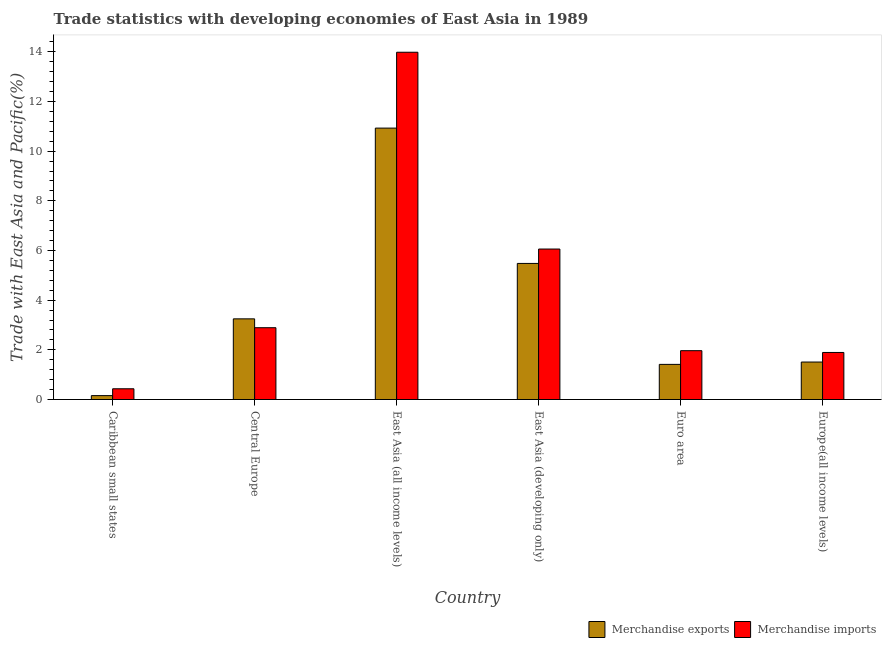How many different coloured bars are there?
Offer a terse response. 2. Are the number of bars per tick equal to the number of legend labels?
Your answer should be compact. Yes. Are the number of bars on each tick of the X-axis equal?
Keep it short and to the point. Yes. How many bars are there on the 1st tick from the right?
Your answer should be compact. 2. What is the label of the 4th group of bars from the left?
Provide a short and direct response. East Asia (developing only). In how many cases, is the number of bars for a given country not equal to the number of legend labels?
Provide a succinct answer. 0. What is the merchandise imports in East Asia (developing only)?
Offer a terse response. 6.06. Across all countries, what is the maximum merchandise imports?
Make the answer very short. 13.98. Across all countries, what is the minimum merchandise exports?
Provide a succinct answer. 0.16. In which country was the merchandise imports maximum?
Your answer should be very brief. East Asia (all income levels). In which country was the merchandise imports minimum?
Offer a terse response. Caribbean small states. What is the total merchandise exports in the graph?
Ensure brevity in your answer.  22.74. What is the difference between the merchandise imports in Central Europe and that in East Asia (developing only)?
Your response must be concise. -3.17. What is the difference between the merchandise exports in Euro area and the merchandise imports in Caribbean small states?
Make the answer very short. 0.98. What is the average merchandise imports per country?
Your response must be concise. 4.54. What is the difference between the merchandise exports and merchandise imports in East Asia (developing only)?
Your response must be concise. -0.58. In how many countries, is the merchandise exports greater than 8.8 %?
Offer a terse response. 1. What is the ratio of the merchandise imports in Central Europe to that in Europe(all income levels)?
Provide a succinct answer. 1.53. Is the merchandise exports in Central Europe less than that in East Asia (all income levels)?
Provide a short and direct response. Yes. What is the difference between the highest and the second highest merchandise exports?
Your answer should be very brief. 5.45. What is the difference between the highest and the lowest merchandise exports?
Offer a terse response. 10.77. How many legend labels are there?
Keep it short and to the point. 2. How are the legend labels stacked?
Offer a terse response. Horizontal. What is the title of the graph?
Ensure brevity in your answer.  Trade statistics with developing economies of East Asia in 1989. What is the label or title of the X-axis?
Give a very brief answer. Country. What is the label or title of the Y-axis?
Offer a terse response. Trade with East Asia and Pacific(%). What is the Trade with East Asia and Pacific(%) of Merchandise exports in Caribbean small states?
Offer a very short reply. 0.16. What is the Trade with East Asia and Pacific(%) of Merchandise imports in Caribbean small states?
Make the answer very short. 0.43. What is the Trade with East Asia and Pacific(%) of Merchandise exports in Central Europe?
Ensure brevity in your answer.  3.25. What is the Trade with East Asia and Pacific(%) of Merchandise imports in Central Europe?
Offer a very short reply. 2.89. What is the Trade with East Asia and Pacific(%) of Merchandise exports in East Asia (all income levels)?
Offer a very short reply. 10.93. What is the Trade with East Asia and Pacific(%) in Merchandise imports in East Asia (all income levels)?
Ensure brevity in your answer.  13.98. What is the Trade with East Asia and Pacific(%) of Merchandise exports in East Asia (developing only)?
Make the answer very short. 5.48. What is the Trade with East Asia and Pacific(%) in Merchandise imports in East Asia (developing only)?
Keep it short and to the point. 6.06. What is the Trade with East Asia and Pacific(%) of Merchandise exports in Euro area?
Your response must be concise. 1.41. What is the Trade with East Asia and Pacific(%) of Merchandise imports in Euro area?
Ensure brevity in your answer.  1.97. What is the Trade with East Asia and Pacific(%) of Merchandise exports in Europe(all income levels)?
Your answer should be compact. 1.51. What is the Trade with East Asia and Pacific(%) in Merchandise imports in Europe(all income levels)?
Offer a terse response. 1.89. Across all countries, what is the maximum Trade with East Asia and Pacific(%) of Merchandise exports?
Offer a terse response. 10.93. Across all countries, what is the maximum Trade with East Asia and Pacific(%) of Merchandise imports?
Your response must be concise. 13.98. Across all countries, what is the minimum Trade with East Asia and Pacific(%) of Merchandise exports?
Your response must be concise. 0.16. Across all countries, what is the minimum Trade with East Asia and Pacific(%) of Merchandise imports?
Offer a very short reply. 0.43. What is the total Trade with East Asia and Pacific(%) of Merchandise exports in the graph?
Keep it short and to the point. 22.74. What is the total Trade with East Asia and Pacific(%) of Merchandise imports in the graph?
Give a very brief answer. 27.23. What is the difference between the Trade with East Asia and Pacific(%) in Merchandise exports in Caribbean small states and that in Central Europe?
Ensure brevity in your answer.  -3.09. What is the difference between the Trade with East Asia and Pacific(%) in Merchandise imports in Caribbean small states and that in Central Europe?
Keep it short and to the point. -2.46. What is the difference between the Trade with East Asia and Pacific(%) of Merchandise exports in Caribbean small states and that in East Asia (all income levels)?
Provide a succinct answer. -10.77. What is the difference between the Trade with East Asia and Pacific(%) in Merchandise imports in Caribbean small states and that in East Asia (all income levels)?
Offer a terse response. -13.55. What is the difference between the Trade with East Asia and Pacific(%) of Merchandise exports in Caribbean small states and that in East Asia (developing only)?
Ensure brevity in your answer.  -5.32. What is the difference between the Trade with East Asia and Pacific(%) of Merchandise imports in Caribbean small states and that in East Asia (developing only)?
Your answer should be very brief. -5.63. What is the difference between the Trade with East Asia and Pacific(%) of Merchandise exports in Caribbean small states and that in Euro area?
Provide a succinct answer. -1.26. What is the difference between the Trade with East Asia and Pacific(%) in Merchandise imports in Caribbean small states and that in Euro area?
Make the answer very short. -1.53. What is the difference between the Trade with East Asia and Pacific(%) of Merchandise exports in Caribbean small states and that in Europe(all income levels)?
Your answer should be very brief. -1.35. What is the difference between the Trade with East Asia and Pacific(%) of Merchandise imports in Caribbean small states and that in Europe(all income levels)?
Offer a very short reply. -1.46. What is the difference between the Trade with East Asia and Pacific(%) of Merchandise exports in Central Europe and that in East Asia (all income levels)?
Provide a succinct answer. -7.68. What is the difference between the Trade with East Asia and Pacific(%) of Merchandise imports in Central Europe and that in East Asia (all income levels)?
Offer a very short reply. -11.09. What is the difference between the Trade with East Asia and Pacific(%) in Merchandise exports in Central Europe and that in East Asia (developing only)?
Offer a terse response. -2.23. What is the difference between the Trade with East Asia and Pacific(%) of Merchandise imports in Central Europe and that in East Asia (developing only)?
Your answer should be compact. -3.17. What is the difference between the Trade with East Asia and Pacific(%) of Merchandise exports in Central Europe and that in Euro area?
Give a very brief answer. 1.83. What is the difference between the Trade with East Asia and Pacific(%) of Merchandise imports in Central Europe and that in Euro area?
Your answer should be compact. 0.92. What is the difference between the Trade with East Asia and Pacific(%) of Merchandise exports in Central Europe and that in Europe(all income levels)?
Your answer should be very brief. 1.74. What is the difference between the Trade with East Asia and Pacific(%) in Merchandise exports in East Asia (all income levels) and that in East Asia (developing only)?
Offer a very short reply. 5.45. What is the difference between the Trade with East Asia and Pacific(%) in Merchandise imports in East Asia (all income levels) and that in East Asia (developing only)?
Your response must be concise. 7.92. What is the difference between the Trade with East Asia and Pacific(%) in Merchandise exports in East Asia (all income levels) and that in Euro area?
Your answer should be very brief. 9.51. What is the difference between the Trade with East Asia and Pacific(%) of Merchandise imports in East Asia (all income levels) and that in Euro area?
Ensure brevity in your answer.  12.02. What is the difference between the Trade with East Asia and Pacific(%) in Merchandise exports in East Asia (all income levels) and that in Europe(all income levels)?
Offer a terse response. 9.42. What is the difference between the Trade with East Asia and Pacific(%) in Merchandise imports in East Asia (all income levels) and that in Europe(all income levels)?
Give a very brief answer. 12.09. What is the difference between the Trade with East Asia and Pacific(%) in Merchandise exports in East Asia (developing only) and that in Euro area?
Offer a terse response. 4.06. What is the difference between the Trade with East Asia and Pacific(%) of Merchandise imports in East Asia (developing only) and that in Euro area?
Offer a terse response. 4.09. What is the difference between the Trade with East Asia and Pacific(%) in Merchandise exports in East Asia (developing only) and that in Europe(all income levels)?
Keep it short and to the point. 3.97. What is the difference between the Trade with East Asia and Pacific(%) in Merchandise imports in East Asia (developing only) and that in Europe(all income levels)?
Offer a terse response. 4.16. What is the difference between the Trade with East Asia and Pacific(%) of Merchandise exports in Euro area and that in Europe(all income levels)?
Provide a short and direct response. -0.09. What is the difference between the Trade with East Asia and Pacific(%) in Merchandise imports in Euro area and that in Europe(all income levels)?
Your response must be concise. 0.07. What is the difference between the Trade with East Asia and Pacific(%) in Merchandise exports in Caribbean small states and the Trade with East Asia and Pacific(%) in Merchandise imports in Central Europe?
Provide a short and direct response. -2.73. What is the difference between the Trade with East Asia and Pacific(%) of Merchandise exports in Caribbean small states and the Trade with East Asia and Pacific(%) of Merchandise imports in East Asia (all income levels)?
Your answer should be very brief. -13.83. What is the difference between the Trade with East Asia and Pacific(%) in Merchandise exports in Caribbean small states and the Trade with East Asia and Pacific(%) in Merchandise imports in East Asia (developing only)?
Your response must be concise. -5.9. What is the difference between the Trade with East Asia and Pacific(%) of Merchandise exports in Caribbean small states and the Trade with East Asia and Pacific(%) of Merchandise imports in Euro area?
Make the answer very short. -1.81. What is the difference between the Trade with East Asia and Pacific(%) of Merchandise exports in Caribbean small states and the Trade with East Asia and Pacific(%) of Merchandise imports in Europe(all income levels)?
Provide a succinct answer. -1.74. What is the difference between the Trade with East Asia and Pacific(%) of Merchandise exports in Central Europe and the Trade with East Asia and Pacific(%) of Merchandise imports in East Asia (all income levels)?
Make the answer very short. -10.73. What is the difference between the Trade with East Asia and Pacific(%) of Merchandise exports in Central Europe and the Trade with East Asia and Pacific(%) of Merchandise imports in East Asia (developing only)?
Offer a very short reply. -2.81. What is the difference between the Trade with East Asia and Pacific(%) of Merchandise exports in Central Europe and the Trade with East Asia and Pacific(%) of Merchandise imports in Euro area?
Your response must be concise. 1.28. What is the difference between the Trade with East Asia and Pacific(%) in Merchandise exports in Central Europe and the Trade with East Asia and Pacific(%) in Merchandise imports in Europe(all income levels)?
Make the answer very short. 1.35. What is the difference between the Trade with East Asia and Pacific(%) of Merchandise exports in East Asia (all income levels) and the Trade with East Asia and Pacific(%) of Merchandise imports in East Asia (developing only)?
Offer a terse response. 4.87. What is the difference between the Trade with East Asia and Pacific(%) in Merchandise exports in East Asia (all income levels) and the Trade with East Asia and Pacific(%) in Merchandise imports in Euro area?
Make the answer very short. 8.96. What is the difference between the Trade with East Asia and Pacific(%) in Merchandise exports in East Asia (all income levels) and the Trade with East Asia and Pacific(%) in Merchandise imports in Europe(all income levels)?
Provide a short and direct response. 9.03. What is the difference between the Trade with East Asia and Pacific(%) of Merchandise exports in East Asia (developing only) and the Trade with East Asia and Pacific(%) of Merchandise imports in Euro area?
Make the answer very short. 3.51. What is the difference between the Trade with East Asia and Pacific(%) in Merchandise exports in East Asia (developing only) and the Trade with East Asia and Pacific(%) in Merchandise imports in Europe(all income levels)?
Ensure brevity in your answer.  3.58. What is the difference between the Trade with East Asia and Pacific(%) in Merchandise exports in Euro area and the Trade with East Asia and Pacific(%) in Merchandise imports in Europe(all income levels)?
Your answer should be very brief. -0.48. What is the average Trade with East Asia and Pacific(%) in Merchandise exports per country?
Provide a short and direct response. 3.79. What is the average Trade with East Asia and Pacific(%) of Merchandise imports per country?
Your response must be concise. 4.54. What is the difference between the Trade with East Asia and Pacific(%) in Merchandise exports and Trade with East Asia and Pacific(%) in Merchandise imports in Caribbean small states?
Keep it short and to the point. -0.28. What is the difference between the Trade with East Asia and Pacific(%) in Merchandise exports and Trade with East Asia and Pacific(%) in Merchandise imports in Central Europe?
Give a very brief answer. 0.36. What is the difference between the Trade with East Asia and Pacific(%) of Merchandise exports and Trade with East Asia and Pacific(%) of Merchandise imports in East Asia (all income levels)?
Keep it short and to the point. -3.05. What is the difference between the Trade with East Asia and Pacific(%) of Merchandise exports and Trade with East Asia and Pacific(%) of Merchandise imports in East Asia (developing only)?
Your answer should be compact. -0.58. What is the difference between the Trade with East Asia and Pacific(%) in Merchandise exports and Trade with East Asia and Pacific(%) in Merchandise imports in Euro area?
Ensure brevity in your answer.  -0.55. What is the difference between the Trade with East Asia and Pacific(%) of Merchandise exports and Trade with East Asia and Pacific(%) of Merchandise imports in Europe(all income levels)?
Give a very brief answer. -0.39. What is the ratio of the Trade with East Asia and Pacific(%) in Merchandise exports in Caribbean small states to that in Central Europe?
Ensure brevity in your answer.  0.05. What is the ratio of the Trade with East Asia and Pacific(%) in Merchandise imports in Caribbean small states to that in Central Europe?
Your response must be concise. 0.15. What is the ratio of the Trade with East Asia and Pacific(%) of Merchandise exports in Caribbean small states to that in East Asia (all income levels)?
Ensure brevity in your answer.  0.01. What is the ratio of the Trade with East Asia and Pacific(%) in Merchandise imports in Caribbean small states to that in East Asia (all income levels)?
Your answer should be compact. 0.03. What is the ratio of the Trade with East Asia and Pacific(%) in Merchandise exports in Caribbean small states to that in East Asia (developing only)?
Offer a very short reply. 0.03. What is the ratio of the Trade with East Asia and Pacific(%) of Merchandise imports in Caribbean small states to that in East Asia (developing only)?
Your answer should be compact. 0.07. What is the ratio of the Trade with East Asia and Pacific(%) in Merchandise exports in Caribbean small states to that in Euro area?
Offer a terse response. 0.11. What is the ratio of the Trade with East Asia and Pacific(%) in Merchandise imports in Caribbean small states to that in Euro area?
Your response must be concise. 0.22. What is the ratio of the Trade with East Asia and Pacific(%) of Merchandise exports in Caribbean small states to that in Europe(all income levels)?
Provide a succinct answer. 0.1. What is the ratio of the Trade with East Asia and Pacific(%) in Merchandise imports in Caribbean small states to that in Europe(all income levels)?
Offer a very short reply. 0.23. What is the ratio of the Trade with East Asia and Pacific(%) in Merchandise exports in Central Europe to that in East Asia (all income levels)?
Offer a terse response. 0.3. What is the ratio of the Trade with East Asia and Pacific(%) in Merchandise imports in Central Europe to that in East Asia (all income levels)?
Ensure brevity in your answer.  0.21. What is the ratio of the Trade with East Asia and Pacific(%) of Merchandise exports in Central Europe to that in East Asia (developing only)?
Provide a succinct answer. 0.59. What is the ratio of the Trade with East Asia and Pacific(%) of Merchandise imports in Central Europe to that in East Asia (developing only)?
Your response must be concise. 0.48. What is the ratio of the Trade with East Asia and Pacific(%) of Merchandise exports in Central Europe to that in Euro area?
Your answer should be very brief. 2.3. What is the ratio of the Trade with East Asia and Pacific(%) of Merchandise imports in Central Europe to that in Euro area?
Offer a very short reply. 1.47. What is the ratio of the Trade with East Asia and Pacific(%) of Merchandise exports in Central Europe to that in Europe(all income levels)?
Your answer should be very brief. 2.15. What is the ratio of the Trade with East Asia and Pacific(%) in Merchandise imports in Central Europe to that in Europe(all income levels)?
Offer a very short reply. 1.53. What is the ratio of the Trade with East Asia and Pacific(%) in Merchandise exports in East Asia (all income levels) to that in East Asia (developing only)?
Make the answer very short. 1.99. What is the ratio of the Trade with East Asia and Pacific(%) of Merchandise imports in East Asia (all income levels) to that in East Asia (developing only)?
Provide a short and direct response. 2.31. What is the ratio of the Trade with East Asia and Pacific(%) of Merchandise exports in East Asia (all income levels) to that in Euro area?
Your answer should be compact. 7.72. What is the ratio of the Trade with East Asia and Pacific(%) in Merchandise imports in East Asia (all income levels) to that in Euro area?
Keep it short and to the point. 7.11. What is the ratio of the Trade with East Asia and Pacific(%) of Merchandise exports in East Asia (all income levels) to that in Europe(all income levels)?
Make the answer very short. 7.24. What is the ratio of the Trade with East Asia and Pacific(%) in Merchandise imports in East Asia (all income levels) to that in Europe(all income levels)?
Offer a very short reply. 7.38. What is the ratio of the Trade with East Asia and Pacific(%) of Merchandise exports in East Asia (developing only) to that in Euro area?
Your response must be concise. 3.87. What is the ratio of the Trade with East Asia and Pacific(%) in Merchandise imports in East Asia (developing only) to that in Euro area?
Provide a succinct answer. 3.08. What is the ratio of the Trade with East Asia and Pacific(%) of Merchandise exports in East Asia (developing only) to that in Europe(all income levels)?
Your answer should be compact. 3.63. What is the ratio of the Trade with East Asia and Pacific(%) of Merchandise imports in East Asia (developing only) to that in Europe(all income levels)?
Your response must be concise. 3.2. What is the ratio of the Trade with East Asia and Pacific(%) of Merchandise exports in Euro area to that in Europe(all income levels)?
Ensure brevity in your answer.  0.94. What is the ratio of the Trade with East Asia and Pacific(%) in Merchandise imports in Euro area to that in Europe(all income levels)?
Give a very brief answer. 1.04. What is the difference between the highest and the second highest Trade with East Asia and Pacific(%) in Merchandise exports?
Offer a very short reply. 5.45. What is the difference between the highest and the second highest Trade with East Asia and Pacific(%) of Merchandise imports?
Offer a very short reply. 7.92. What is the difference between the highest and the lowest Trade with East Asia and Pacific(%) in Merchandise exports?
Offer a terse response. 10.77. What is the difference between the highest and the lowest Trade with East Asia and Pacific(%) of Merchandise imports?
Offer a terse response. 13.55. 